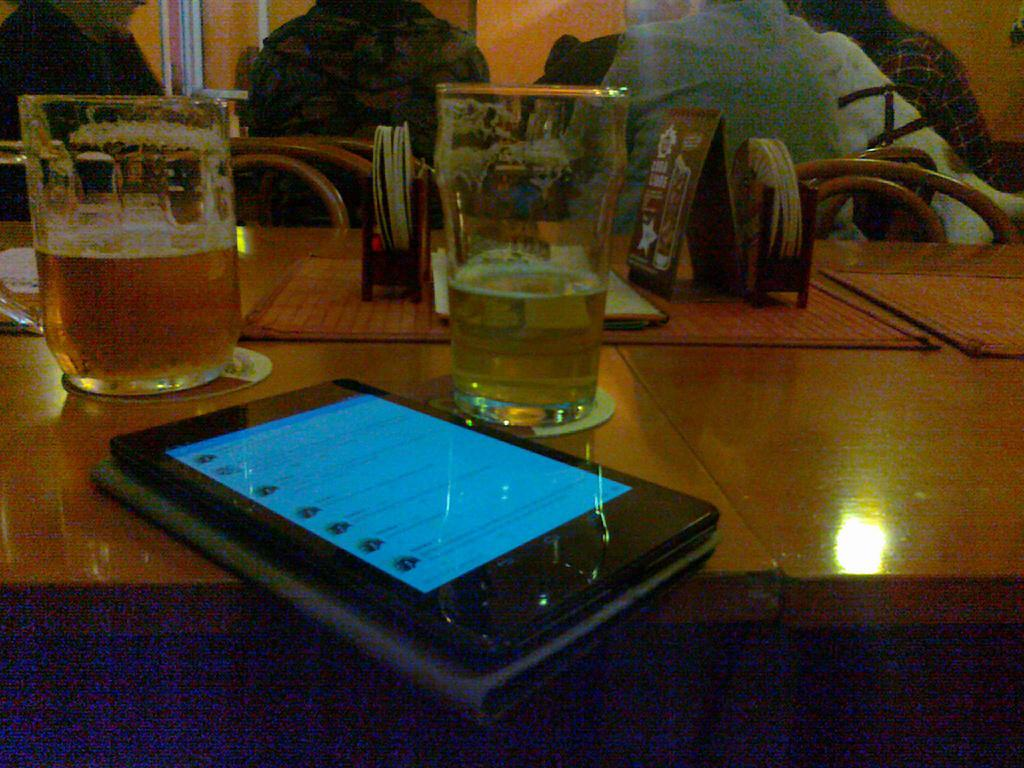How many glasses can be seen in the image? There are 2 glasses in the image. What other object is present on the table? There is a mobile phone in the image. Can you describe the other items on the table? There are other things on the table, but their specific details are not mentioned in the facts. Are there any people visible in the image? Yes, there are people visible in the image. What type of robin is sitting on the mobile phone in the image? There is no robin present in the image; it only mentions a mobile phone and people. What parenting advice can be seen on the table in the image? There is no parenting advice visible in the image; it only mentions a mobile phone and people. 